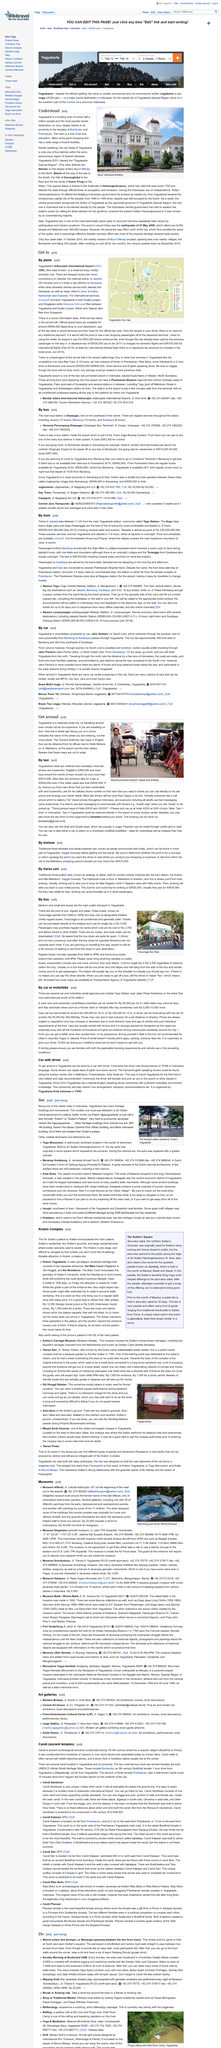Point out several critical features in this image. The cost of renting a motorbike is significantly lower than the cost of renting a car, making it a more affordable option for individuals looking to rent a vehicle. Horse-drawn carriages and bike-powered carriages are the traditional modes of transportation in Yogyakarta, which are widely used by the locals. One of the ways to get in is by plane, yes, it is. Yes, it is possible to find English-speaking drivers in Yogyakarta. TransJogja bus tickets in Yogyakarta can be purchased directly at shelters for a single trip at a cost of Rp 3,000, and the fare is subject to change. 